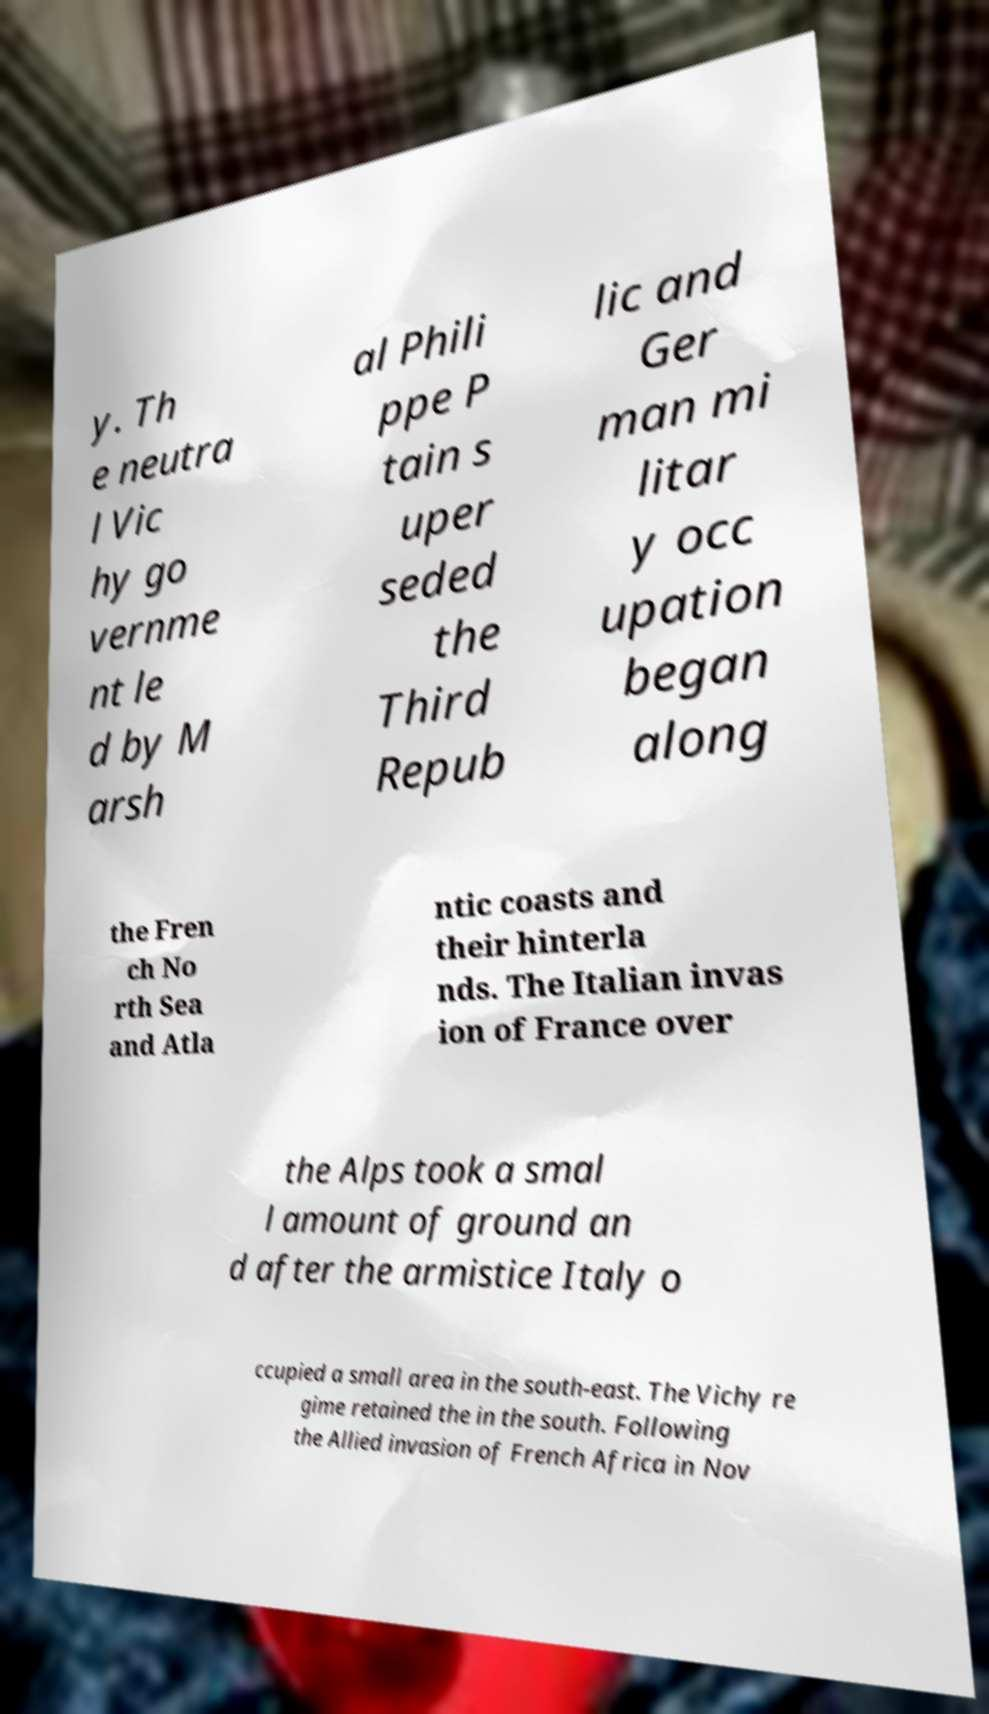Please identify and transcribe the text found in this image. y. Th e neutra l Vic hy go vernme nt le d by M arsh al Phili ppe P tain s uper seded the Third Repub lic and Ger man mi litar y occ upation began along the Fren ch No rth Sea and Atla ntic coasts and their hinterla nds. The Italian invas ion of France over the Alps took a smal l amount of ground an d after the armistice Italy o ccupied a small area in the south-east. The Vichy re gime retained the in the south. Following the Allied invasion of French Africa in Nov 